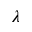<formula> <loc_0><loc_0><loc_500><loc_500>\lambda</formula> 